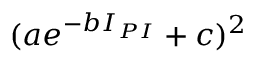Convert formula to latex. <formula><loc_0><loc_0><loc_500><loc_500>( a e ^ { - b I _ { P I } } + c ) ^ { 2 }</formula> 